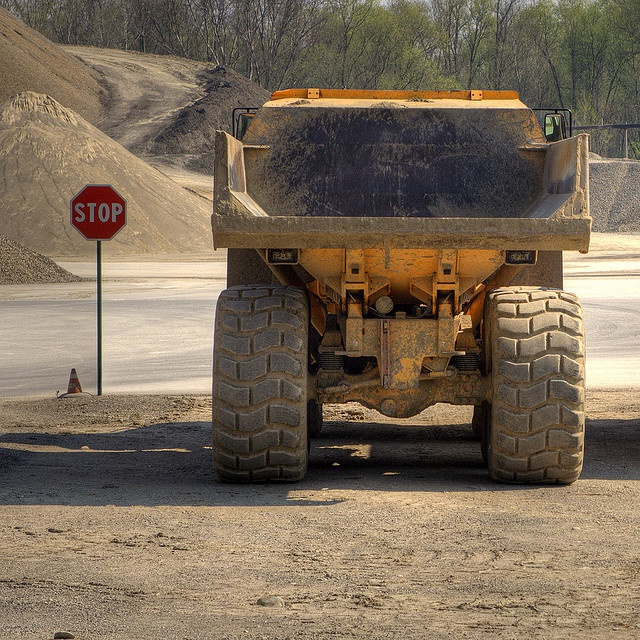Describe the objects in this image and their specific colors. I can see truck in gray, black, and maroon tones and stop sign in gray, maroon, tan, and purple tones in this image. 